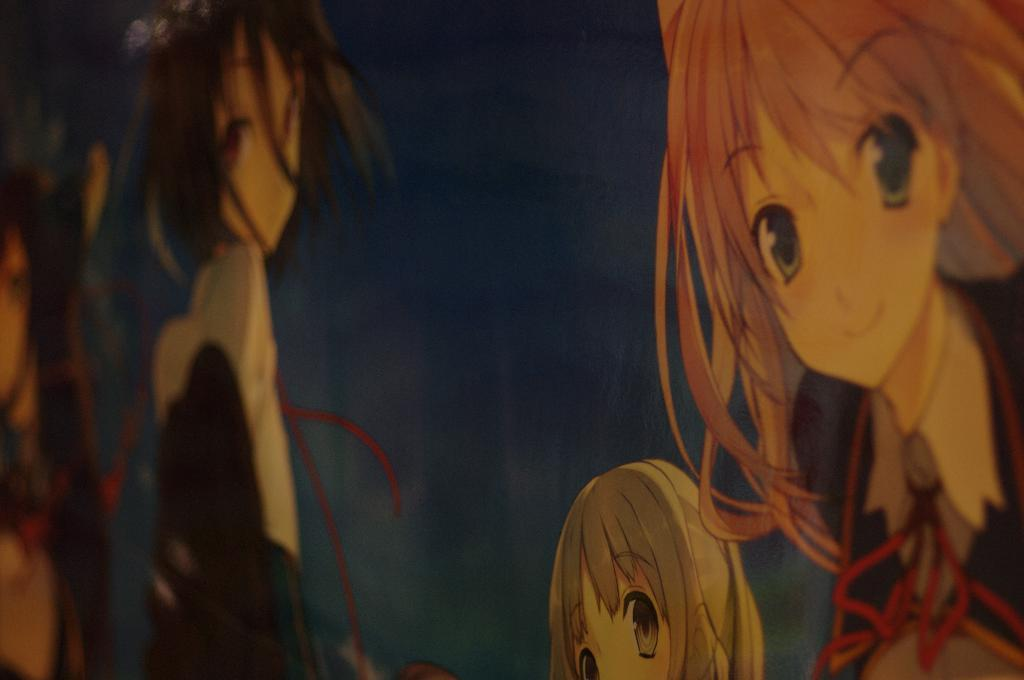How many cartoon images are present in the picture? There are four cartoon images in the picture. What is the expression on the faces of the cartoon images? Two of the cartoon images are smiling. What gender are the cartoon images? The cartoon images are of girls. What is the color of the background in the image? The background of the image is dark. What type of tooth is visible in the image? There is no tooth present in the image; it features four cartoon images of girls. How much is the payment for the cartoon images in the image? There is no indication of payment in the image; it simply displays the cartoon images. 